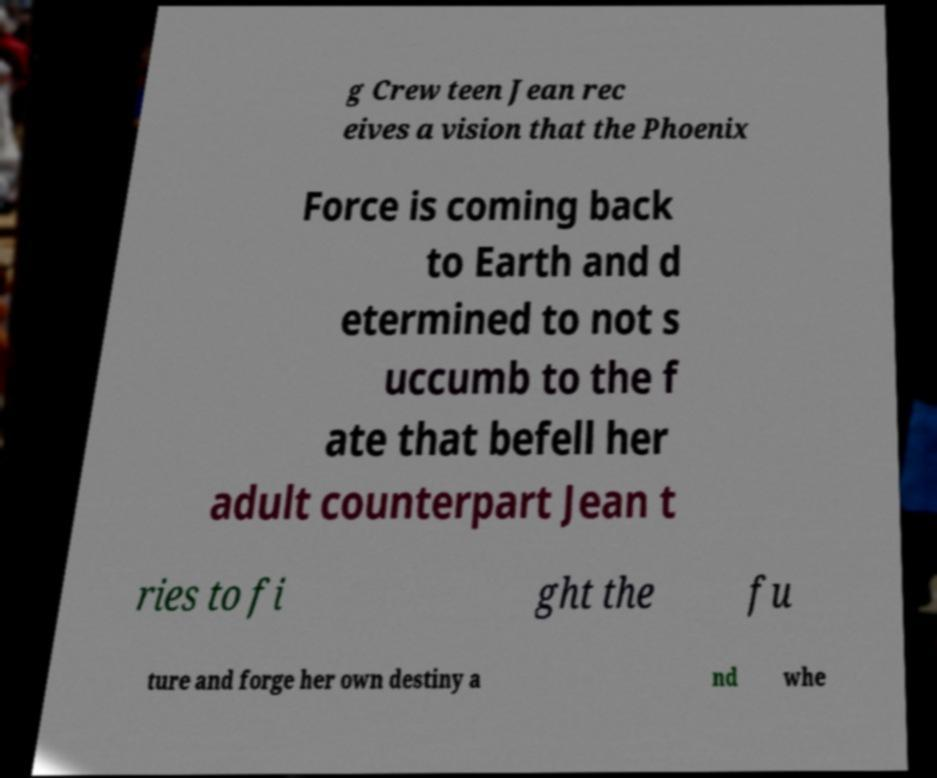Could you extract and type out the text from this image? g Crew teen Jean rec eives a vision that the Phoenix Force is coming back to Earth and d etermined to not s uccumb to the f ate that befell her adult counterpart Jean t ries to fi ght the fu ture and forge her own destiny a nd whe 